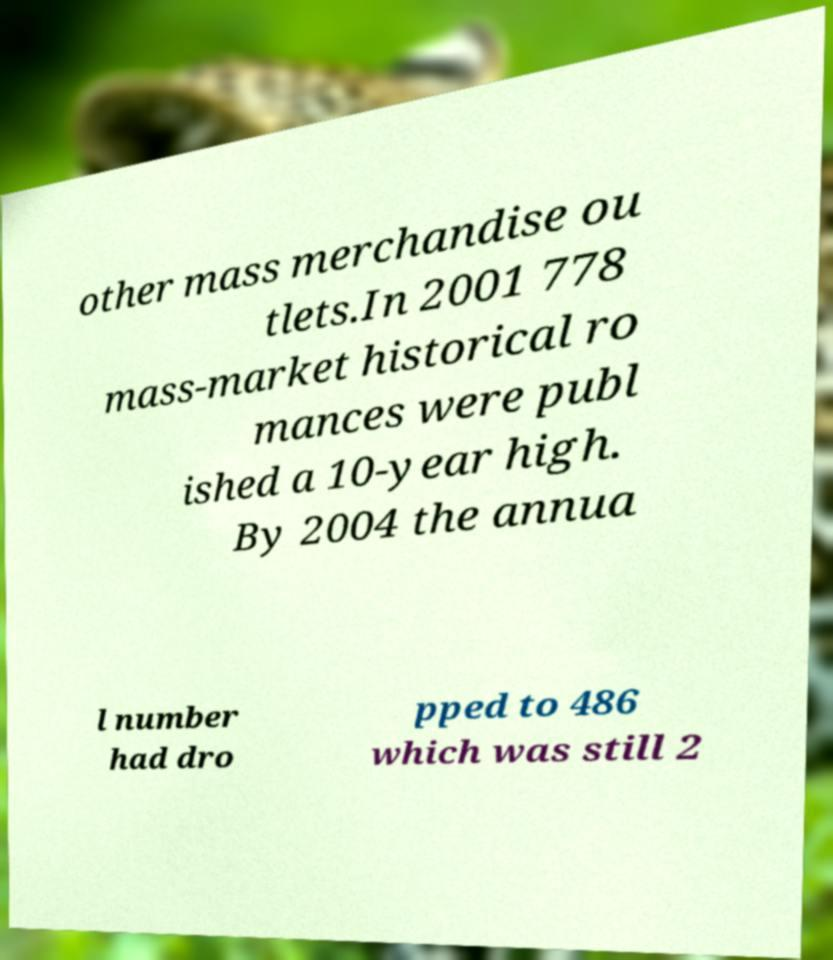I need the written content from this picture converted into text. Can you do that? other mass merchandise ou tlets.In 2001 778 mass-market historical ro mances were publ ished a 10-year high. By 2004 the annua l number had dro pped to 486 which was still 2 